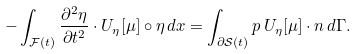<formula> <loc_0><loc_0><loc_500><loc_500>- \int _ { { \mathcal { F } } ( t ) } \frac { \partial ^ { 2 } \eta } { \partial t ^ { 2 } } \cdot U _ { \eta } [ \mu ] \circ \eta \, d x = \int _ { \partial \mathcal { S } ( t ) } p \, U _ { \eta } [ \mu ] \cdot n \, d \Gamma .</formula> 